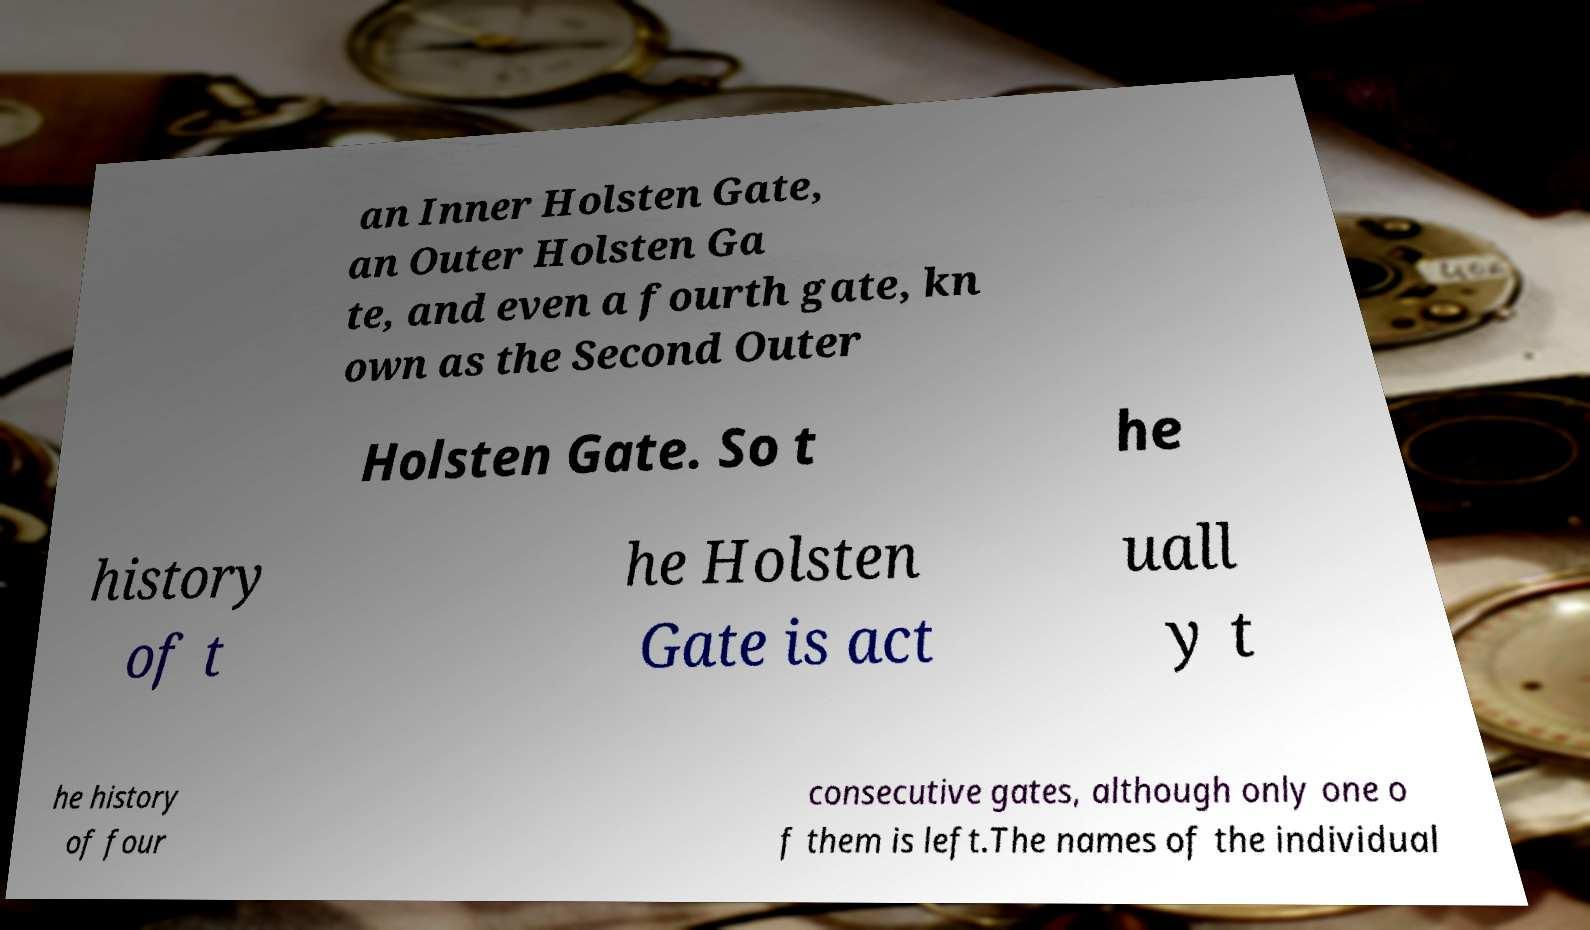Could you assist in decoding the text presented in this image and type it out clearly? an Inner Holsten Gate, an Outer Holsten Ga te, and even a fourth gate, kn own as the Second Outer Holsten Gate. So t he history of t he Holsten Gate is act uall y t he history of four consecutive gates, although only one o f them is left.The names of the individual 